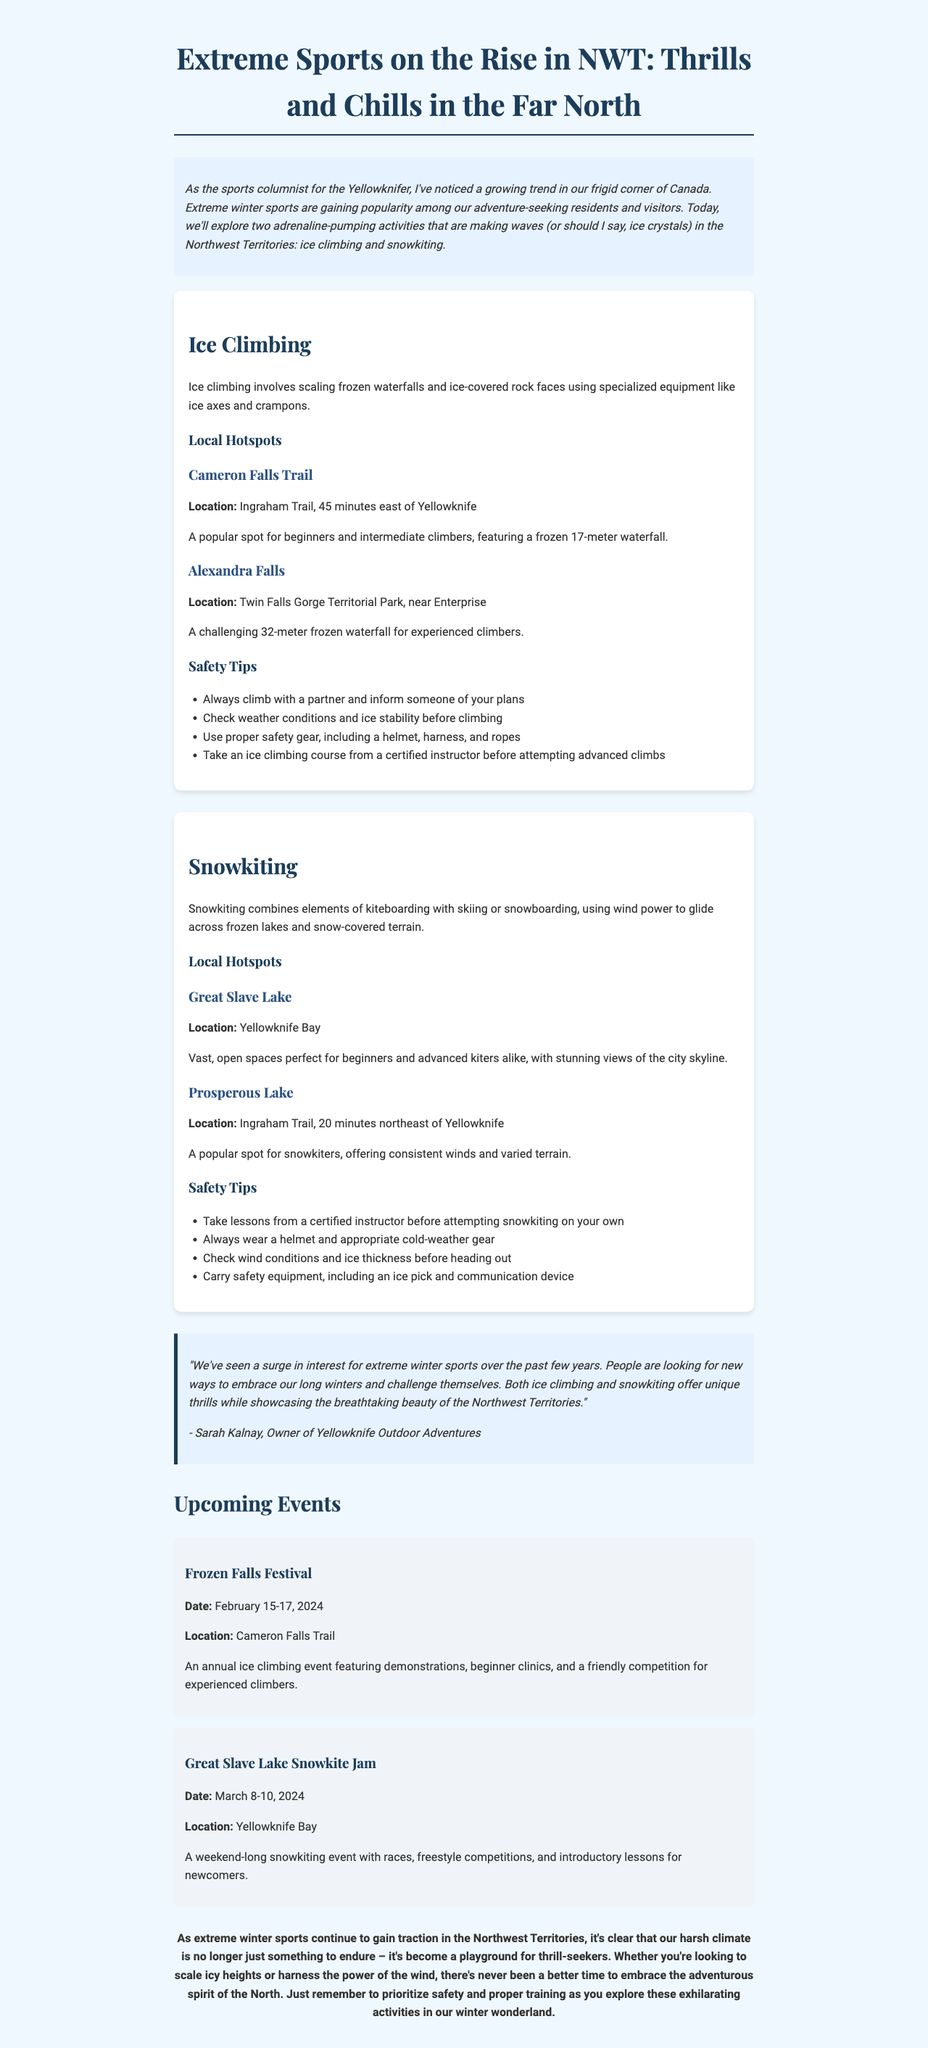What are the two extreme sports gaining traction in NWT? The newsletter highlights ice climbing and snowkiting as the two extreme sports gaining popularity.
Answer: ice climbing and snowkiting What is the height of the frozen waterfall at Cameron Falls Trail? The description states that Cameron Falls features a frozen 17-meter waterfall, making it a great spot for beginners.
Answer: 17-meter Who is the owner of Yellowknife Outdoor Adventures? The newsletter includes a quote from Sarah Kalnay, who is identified as the owner of Yellowknife Outdoor Adventures.
Answer: Sarah Kalnay What date is the Frozen Falls Festival scheduled for? The upcoming events section lists the Frozen Falls Festival from February 15-17, 2024.
Answer: February 15-17, 2024 What should you always wear while snowkiting according to the safety tips? The safety tips for snowkiting recommend always wearing a helmet and appropriate cold-weather gear.
Answer: helmet and appropriate cold-weather gear What is the location of the Great Slave Lake? The newsletter specifies that Great Slave Lake is located at Yellowknife Bay, making it a popular spot for snowkiting.
Answer: Yellowknife Bay How many safety tips are provided for ice climbing? The section on ice climbing outlines four distinct safety tips for climbers to follow.
Answer: four What type of event is the Great Slave Lake Snowkite Jam? The Great Slave Lake Snowkite Jam is described as a weekend-long snowkiting event with various competitions and lessons.
Answer: snowkiting event 